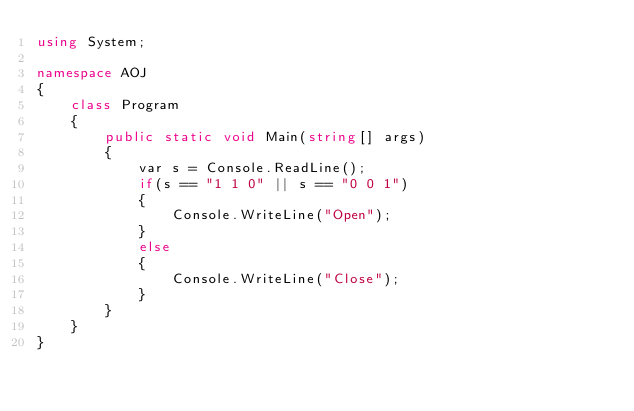<code> <loc_0><loc_0><loc_500><loc_500><_C#_>using System;

namespace AOJ
{
	class Program
	{
		public static void Main(string[] args)
		{
			var s = Console.ReadLine();
			if(s == "1 1 0" || s == "0 0 1")
			{
				Console.WriteLine("Open");
			}
			else
			{
				Console.WriteLine("Close");
			}
		}
	}
}</code> 